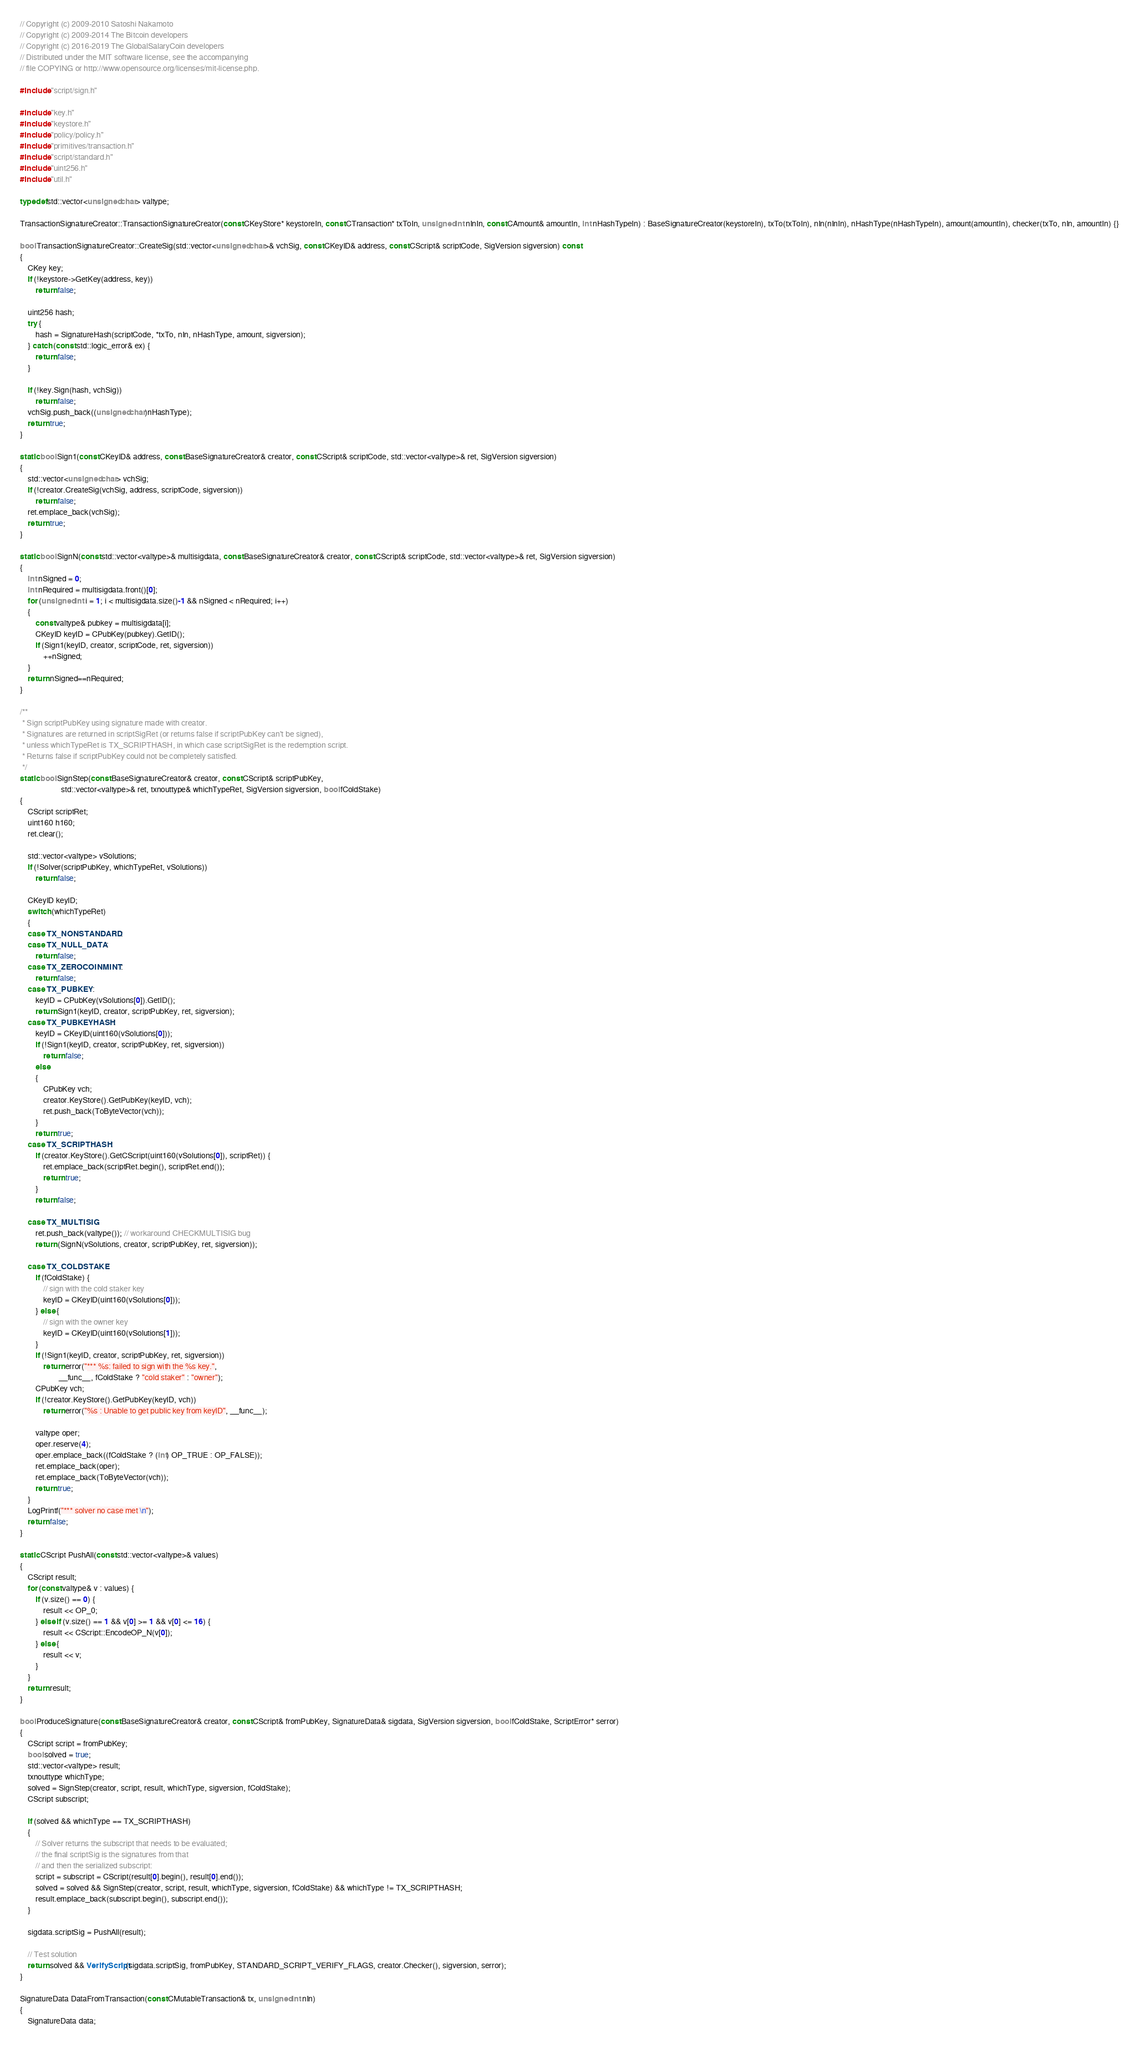<code> <loc_0><loc_0><loc_500><loc_500><_C++_>// Copyright (c) 2009-2010 Satoshi Nakamoto
// Copyright (c) 2009-2014 The Bitcoin developers
// Copyright (c) 2016-2019 The GlobalSalaryCoin developers
// Distributed under the MIT software license, see the accompanying
// file COPYING or http://www.opensource.org/licenses/mit-license.php.

#include "script/sign.h"

#include "key.h"
#include "keystore.h"
#include "policy/policy.h"
#include "primitives/transaction.h"
#include "script/standard.h"
#include "uint256.h"
#include "util.h"

typedef std::vector<unsigned char> valtype;

TransactionSignatureCreator::TransactionSignatureCreator(const CKeyStore* keystoreIn, const CTransaction* txToIn, unsigned int nInIn, const CAmount& amountIn, int nHashTypeIn) : BaseSignatureCreator(keystoreIn), txTo(txToIn), nIn(nInIn), nHashType(nHashTypeIn), amount(amountIn), checker(txTo, nIn, amountIn) {}

bool TransactionSignatureCreator::CreateSig(std::vector<unsigned char>& vchSig, const CKeyID& address, const CScript& scriptCode, SigVersion sigversion) const
{
    CKey key;
    if (!keystore->GetKey(address, key))
        return false;

    uint256 hash;
    try {
        hash = SignatureHash(scriptCode, *txTo, nIn, nHashType, amount, sigversion);
    } catch (const std::logic_error& ex) {
        return false;
    }

    if (!key.Sign(hash, vchSig))
        return false;
    vchSig.push_back((unsigned char)nHashType);
    return true;
}

static bool Sign1(const CKeyID& address, const BaseSignatureCreator& creator, const CScript& scriptCode, std::vector<valtype>& ret, SigVersion sigversion)
{
    std::vector<unsigned char> vchSig;
    if (!creator.CreateSig(vchSig, address, scriptCode, sigversion))
        return false;
    ret.emplace_back(vchSig);
    return true;
}

static bool SignN(const std::vector<valtype>& multisigdata, const BaseSignatureCreator& creator, const CScript& scriptCode, std::vector<valtype>& ret, SigVersion sigversion)
{
    int nSigned = 0;
    int nRequired = multisigdata.front()[0];
    for (unsigned int i = 1; i < multisigdata.size()-1 && nSigned < nRequired; i++)
    {
        const valtype& pubkey = multisigdata[i];
        CKeyID keyID = CPubKey(pubkey).GetID();
        if (Sign1(keyID, creator, scriptCode, ret, sigversion))
            ++nSigned;
    }
    return nSigned==nRequired;
}

/**
 * Sign scriptPubKey using signature made with creator.
 * Signatures are returned in scriptSigRet (or returns false if scriptPubKey can't be signed),
 * unless whichTypeRet is TX_SCRIPTHASH, in which case scriptSigRet is the redemption script.
 * Returns false if scriptPubKey could not be completely satisfied.
 */
static bool SignStep(const BaseSignatureCreator& creator, const CScript& scriptPubKey,
                     std::vector<valtype>& ret, txnouttype& whichTypeRet, SigVersion sigversion, bool fColdStake)
{
    CScript scriptRet;
    uint160 h160;
    ret.clear();

    std::vector<valtype> vSolutions;
    if (!Solver(scriptPubKey, whichTypeRet, vSolutions))
        return false;

    CKeyID keyID;
    switch (whichTypeRet)
    {
    case TX_NONSTANDARD:
    case TX_NULL_DATA:
        return false;
    case TX_ZEROCOINMINT:
        return false;
    case TX_PUBKEY:
        keyID = CPubKey(vSolutions[0]).GetID();
        return Sign1(keyID, creator, scriptPubKey, ret, sigversion);
    case TX_PUBKEYHASH:
        keyID = CKeyID(uint160(vSolutions[0]));
        if (!Sign1(keyID, creator, scriptPubKey, ret, sigversion))
            return false;
        else
        {
            CPubKey vch;
            creator.KeyStore().GetPubKey(keyID, vch);
            ret.push_back(ToByteVector(vch));
        }
        return true;
    case TX_SCRIPTHASH:
        if (creator.KeyStore().GetCScript(uint160(vSolutions[0]), scriptRet)) {
            ret.emplace_back(scriptRet.begin(), scriptRet.end());
            return true;
        }
        return false;

    case TX_MULTISIG:
        ret.push_back(valtype()); // workaround CHECKMULTISIG bug
        return (SignN(vSolutions, creator, scriptPubKey, ret, sigversion));

    case TX_COLDSTAKE:
        if (fColdStake) {
            // sign with the cold staker key
            keyID = CKeyID(uint160(vSolutions[0]));
        } else {
            // sign with the owner key
            keyID = CKeyID(uint160(vSolutions[1]));
        }
        if (!Sign1(keyID, creator, scriptPubKey, ret, sigversion))
            return error("*** %s: failed to sign with the %s key.",
                    __func__, fColdStake ? "cold staker" : "owner");
        CPubKey vch;
        if (!creator.KeyStore().GetPubKey(keyID, vch))
            return error("%s : Unable to get public key from keyID", __func__);

        valtype oper;
        oper.reserve(4);
        oper.emplace_back((fColdStake ? (int) OP_TRUE : OP_FALSE));
        ret.emplace_back(oper);
        ret.emplace_back(ToByteVector(vch));
        return true;
    }
    LogPrintf("*** solver no case met \n");
    return false;
}

static CScript PushAll(const std::vector<valtype>& values)
{
    CScript result;
    for (const valtype& v : values) {
        if (v.size() == 0) {
            result << OP_0;
        } else if (v.size() == 1 && v[0] >= 1 && v[0] <= 16) {
            result << CScript::EncodeOP_N(v[0]);
        } else {
            result << v;
        }
    }
    return result;
}

bool ProduceSignature(const BaseSignatureCreator& creator, const CScript& fromPubKey, SignatureData& sigdata, SigVersion sigversion, bool fColdStake, ScriptError* serror)
{
    CScript script = fromPubKey;
    bool solved = true;
    std::vector<valtype> result;
    txnouttype whichType;
    solved = SignStep(creator, script, result, whichType, sigversion, fColdStake);
    CScript subscript;

    if (solved && whichType == TX_SCRIPTHASH)
    {
        // Solver returns the subscript that needs to be evaluated;
        // the final scriptSig is the signatures from that
        // and then the serialized subscript:
        script = subscript = CScript(result[0].begin(), result[0].end());
        solved = solved && SignStep(creator, script, result, whichType, sigversion, fColdStake) && whichType != TX_SCRIPTHASH;
        result.emplace_back(subscript.begin(), subscript.end());
    }

    sigdata.scriptSig = PushAll(result);

    // Test solution
    return solved && VerifyScript(sigdata.scriptSig, fromPubKey, STANDARD_SCRIPT_VERIFY_FLAGS, creator.Checker(), sigversion, serror);
}

SignatureData DataFromTransaction(const CMutableTransaction& tx, unsigned int nIn)
{
    SignatureData data;</code> 